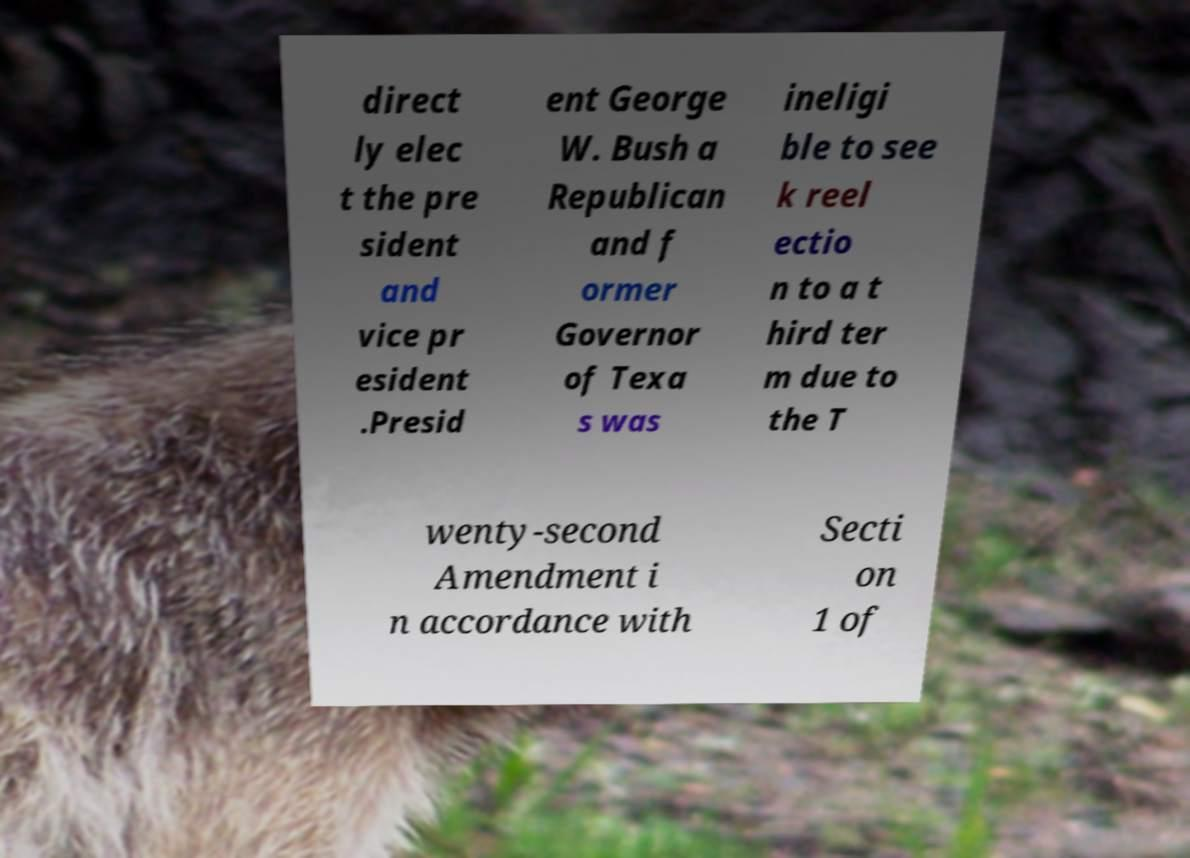Please identify and transcribe the text found in this image. direct ly elec t the pre sident and vice pr esident .Presid ent George W. Bush a Republican and f ormer Governor of Texa s was ineligi ble to see k reel ectio n to a t hird ter m due to the T wenty-second Amendment i n accordance with Secti on 1 of 